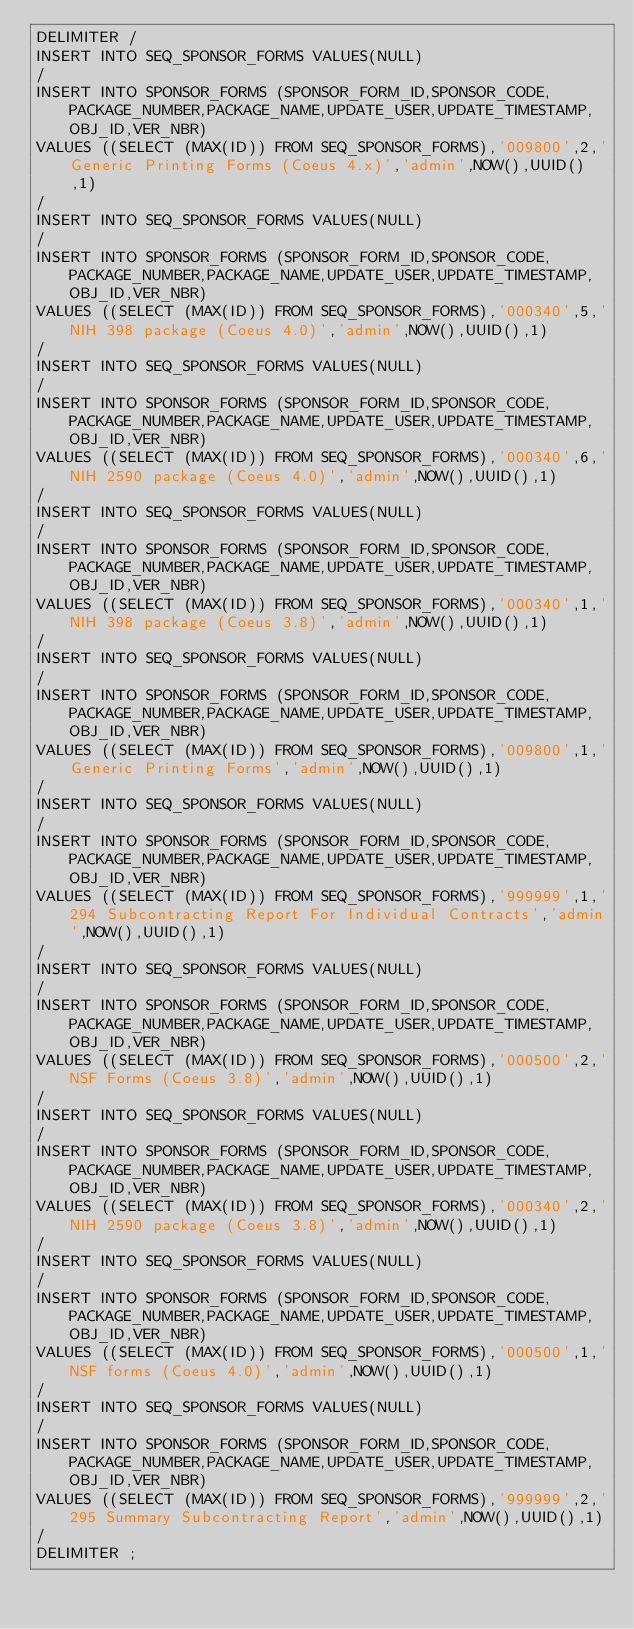<code> <loc_0><loc_0><loc_500><loc_500><_SQL_>DELIMITER /
INSERT INTO SEQ_SPONSOR_FORMS VALUES(NULL)
/
INSERT INTO SPONSOR_FORMS (SPONSOR_FORM_ID,SPONSOR_CODE,PACKAGE_NUMBER,PACKAGE_NAME,UPDATE_USER,UPDATE_TIMESTAMP,OBJ_ID,VER_NBR) 
VALUES ((SELECT (MAX(ID)) FROM SEQ_SPONSOR_FORMS),'009800',2,'Generic Printing Forms (Coeus 4.x)','admin',NOW(),UUID(),1)
/
INSERT INTO SEQ_SPONSOR_FORMS VALUES(NULL)
/
INSERT INTO SPONSOR_FORMS (SPONSOR_FORM_ID,SPONSOR_CODE,PACKAGE_NUMBER,PACKAGE_NAME,UPDATE_USER,UPDATE_TIMESTAMP,OBJ_ID,VER_NBR) 
VALUES ((SELECT (MAX(ID)) FROM SEQ_SPONSOR_FORMS),'000340',5,'NIH 398 package (Coeus 4.0)','admin',NOW(),UUID(),1)
/
INSERT INTO SEQ_SPONSOR_FORMS VALUES(NULL)
/
INSERT INTO SPONSOR_FORMS (SPONSOR_FORM_ID,SPONSOR_CODE,PACKAGE_NUMBER,PACKAGE_NAME,UPDATE_USER,UPDATE_TIMESTAMP,OBJ_ID,VER_NBR) 
VALUES ((SELECT (MAX(ID)) FROM SEQ_SPONSOR_FORMS),'000340',6,'NIH 2590 package (Coeus 4.0)','admin',NOW(),UUID(),1)
/
INSERT INTO SEQ_SPONSOR_FORMS VALUES(NULL)
/
INSERT INTO SPONSOR_FORMS (SPONSOR_FORM_ID,SPONSOR_CODE,PACKAGE_NUMBER,PACKAGE_NAME,UPDATE_USER,UPDATE_TIMESTAMP,OBJ_ID,VER_NBR) 
VALUES ((SELECT (MAX(ID)) FROM SEQ_SPONSOR_FORMS),'000340',1,'NIH 398 package (Coeus 3.8)','admin',NOW(),UUID(),1)
/
INSERT INTO SEQ_SPONSOR_FORMS VALUES(NULL)
/
INSERT INTO SPONSOR_FORMS (SPONSOR_FORM_ID,SPONSOR_CODE,PACKAGE_NUMBER,PACKAGE_NAME,UPDATE_USER,UPDATE_TIMESTAMP,OBJ_ID,VER_NBR) 
VALUES ((SELECT (MAX(ID)) FROM SEQ_SPONSOR_FORMS),'009800',1,'Generic Printing Forms','admin',NOW(),UUID(),1)
/
INSERT INTO SEQ_SPONSOR_FORMS VALUES(NULL)
/
INSERT INTO SPONSOR_FORMS (SPONSOR_FORM_ID,SPONSOR_CODE,PACKAGE_NUMBER,PACKAGE_NAME,UPDATE_USER,UPDATE_TIMESTAMP,OBJ_ID,VER_NBR) 
VALUES ((SELECT (MAX(ID)) FROM SEQ_SPONSOR_FORMS),'999999',1,'294 Subcontracting Report For Individual Contracts','admin',NOW(),UUID(),1)
/
INSERT INTO SEQ_SPONSOR_FORMS VALUES(NULL)
/
INSERT INTO SPONSOR_FORMS (SPONSOR_FORM_ID,SPONSOR_CODE,PACKAGE_NUMBER,PACKAGE_NAME,UPDATE_USER,UPDATE_TIMESTAMP,OBJ_ID,VER_NBR) 
VALUES ((SELECT (MAX(ID)) FROM SEQ_SPONSOR_FORMS),'000500',2,'NSF Forms (Coeus 3.8)','admin',NOW(),UUID(),1)
/
INSERT INTO SEQ_SPONSOR_FORMS VALUES(NULL)
/
INSERT INTO SPONSOR_FORMS (SPONSOR_FORM_ID,SPONSOR_CODE,PACKAGE_NUMBER,PACKAGE_NAME,UPDATE_USER,UPDATE_TIMESTAMP,OBJ_ID,VER_NBR) 
VALUES ((SELECT (MAX(ID)) FROM SEQ_SPONSOR_FORMS),'000340',2,'NIH 2590 package (Coeus 3.8)','admin',NOW(),UUID(),1)
/
INSERT INTO SEQ_SPONSOR_FORMS VALUES(NULL)
/
INSERT INTO SPONSOR_FORMS (SPONSOR_FORM_ID,SPONSOR_CODE,PACKAGE_NUMBER,PACKAGE_NAME,UPDATE_USER,UPDATE_TIMESTAMP,OBJ_ID,VER_NBR) 
VALUES ((SELECT (MAX(ID)) FROM SEQ_SPONSOR_FORMS),'000500',1,'NSF forms (Coeus 4.0)','admin',NOW(),UUID(),1)
/
INSERT INTO SEQ_SPONSOR_FORMS VALUES(NULL)
/
INSERT INTO SPONSOR_FORMS (SPONSOR_FORM_ID,SPONSOR_CODE,PACKAGE_NUMBER,PACKAGE_NAME,UPDATE_USER,UPDATE_TIMESTAMP,OBJ_ID,VER_NBR) 
VALUES ((SELECT (MAX(ID)) FROM SEQ_SPONSOR_FORMS),'999999',2,'295 Summary Subcontracting Report','admin',NOW(),UUID(),1)
/
DELIMITER ;
</code> 